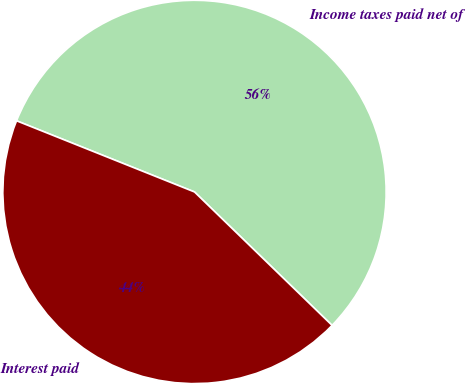Convert chart to OTSL. <chart><loc_0><loc_0><loc_500><loc_500><pie_chart><fcel>Income taxes paid net of<fcel>Interest paid<nl><fcel>56.2%<fcel>43.8%<nl></chart> 